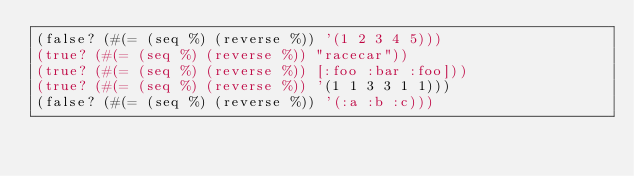Convert code to text. <code><loc_0><loc_0><loc_500><loc_500><_Clojure_>(false? (#(= (seq %) (reverse %)) '(1 2 3 4 5)))
(true? (#(= (seq %) (reverse %)) "racecar"))
(true? (#(= (seq %) (reverse %)) [:foo :bar :foo]))
(true? (#(= (seq %) (reverse %)) '(1 1 3 3 1 1)))
(false? (#(= (seq %) (reverse %)) '(:a :b :c)))
</code> 